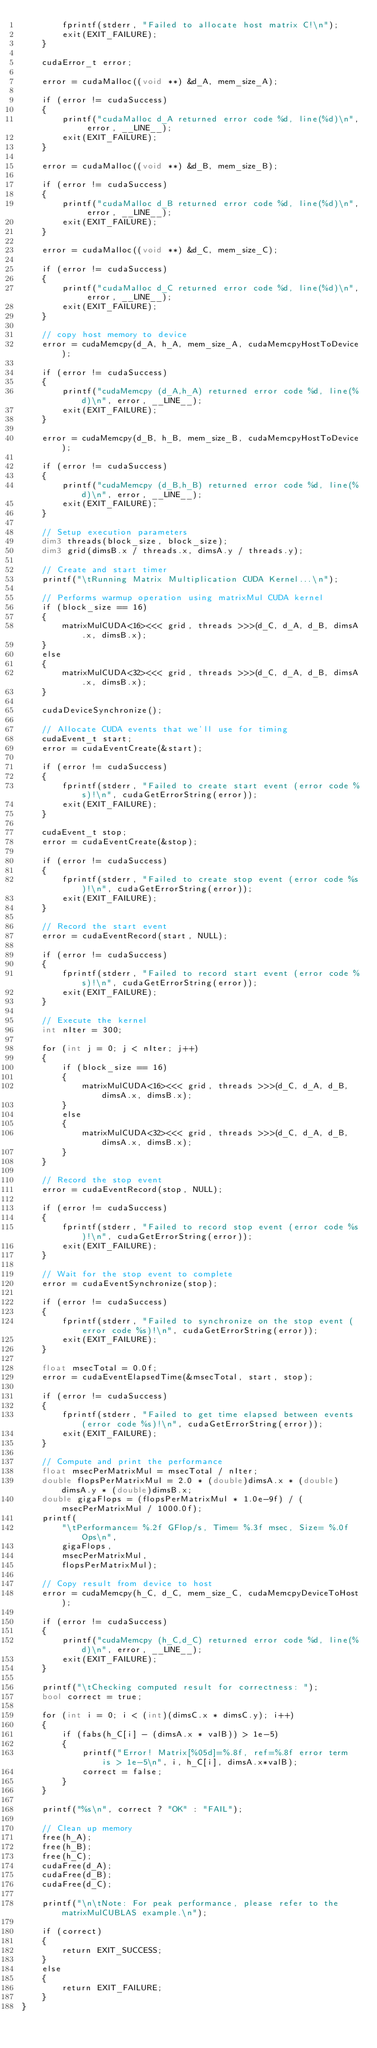<code> <loc_0><loc_0><loc_500><loc_500><_Cuda_>        fprintf(stderr, "Failed to allocate host matrix C!\n");
        exit(EXIT_FAILURE);
    }

    cudaError_t error;

    error = cudaMalloc((void **) &d_A, mem_size_A);

    if (error != cudaSuccess)
    {
        printf("cudaMalloc d_A returned error code %d, line(%d)\n", error, __LINE__);
        exit(EXIT_FAILURE);
    }

    error = cudaMalloc((void **) &d_B, mem_size_B);

    if (error != cudaSuccess)
    {
        printf("cudaMalloc d_B returned error code %d, line(%d)\n", error, __LINE__);
        exit(EXIT_FAILURE);
    }

    error = cudaMalloc((void **) &d_C, mem_size_C);

    if (error != cudaSuccess)
    {
        printf("cudaMalloc d_C returned error code %d, line(%d)\n", error, __LINE__);
        exit(EXIT_FAILURE);
    }

    // copy host memory to device
    error = cudaMemcpy(d_A, h_A, mem_size_A, cudaMemcpyHostToDevice);

    if (error != cudaSuccess)
    {
        printf("cudaMemcpy (d_A,h_A) returned error code %d, line(%d)\n", error, __LINE__);
        exit(EXIT_FAILURE);
    }

    error = cudaMemcpy(d_B, h_B, mem_size_B, cudaMemcpyHostToDevice);

    if (error != cudaSuccess)
    {
        printf("cudaMemcpy (d_B,h_B) returned error code %d, line(%d)\n", error, __LINE__);
        exit(EXIT_FAILURE);
    }

    // Setup execution parameters
    dim3 threads(block_size, block_size);
    dim3 grid(dimsB.x / threads.x, dimsA.y / threads.y);

    // Create and start timer
    printf("\tRunning Matrix Multiplication CUDA Kernel...\n");

    // Performs warmup operation using matrixMul CUDA kernel
    if (block_size == 16)
    {
        matrixMulCUDA<16><<< grid, threads >>>(d_C, d_A, d_B, dimsA.x, dimsB.x);
    }
    else
    {
        matrixMulCUDA<32><<< grid, threads >>>(d_C, d_A, d_B, dimsA.x, dimsB.x);
    }

    cudaDeviceSynchronize();

    // Allocate CUDA events that we'll use for timing
    cudaEvent_t start;
    error = cudaEventCreate(&start);

    if (error != cudaSuccess)
    {
        fprintf(stderr, "Failed to create start event (error code %s)!\n", cudaGetErrorString(error));
        exit(EXIT_FAILURE);
    }

    cudaEvent_t stop;
    error = cudaEventCreate(&stop);

    if (error != cudaSuccess)
    {
        fprintf(stderr, "Failed to create stop event (error code %s)!\n", cudaGetErrorString(error));
        exit(EXIT_FAILURE);
    }

    // Record the start event
    error = cudaEventRecord(start, NULL);

    if (error != cudaSuccess)
    {
        fprintf(stderr, "Failed to record start event (error code %s)!\n", cudaGetErrorString(error));
        exit(EXIT_FAILURE);
    }

    // Execute the kernel
    int nIter = 300;

    for (int j = 0; j < nIter; j++)
    {
        if (block_size == 16)
        {
            matrixMulCUDA<16><<< grid, threads >>>(d_C, d_A, d_B, dimsA.x, dimsB.x);
        }
        else
        {
            matrixMulCUDA<32><<< grid, threads >>>(d_C, d_A, d_B, dimsA.x, dimsB.x);
        }
    }

    // Record the stop event
    error = cudaEventRecord(stop, NULL);

    if (error != cudaSuccess)
    {
        fprintf(stderr, "Failed to record stop event (error code %s)!\n", cudaGetErrorString(error));
        exit(EXIT_FAILURE);
    }

    // Wait for the stop event to complete
    error = cudaEventSynchronize(stop);

    if (error != cudaSuccess)
    {
        fprintf(stderr, "Failed to synchronize on the stop event (error code %s)!\n", cudaGetErrorString(error));
        exit(EXIT_FAILURE);
    }

    float msecTotal = 0.0f;
    error = cudaEventElapsedTime(&msecTotal, start, stop);

    if (error != cudaSuccess)
    {
        fprintf(stderr, "Failed to get time elapsed between events (error code %s)!\n", cudaGetErrorString(error));
        exit(EXIT_FAILURE);
    }

    // Compute and print the performance
    float msecPerMatrixMul = msecTotal / nIter;
    double flopsPerMatrixMul = 2.0 * (double)dimsA.x * (double)dimsA.y * (double)dimsB.x;
    double gigaFlops = (flopsPerMatrixMul * 1.0e-9f) / (msecPerMatrixMul / 1000.0f);
    printf(
        "\tPerformance= %.2f GFlop/s, Time= %.3f msec, Size= %.0f Ops\n",
        gigaFlops,
        msecPerMatrixMul,
        flopsPerMatrixMul);

    // Copy result from device to host
    error = cudaMemcpy(h_C, d_C, mem_size_C, cudaMemcpyDeviceToHost);

    if (error != cudaSuccess)
    {
        printf("cudaMemcpy (h_C,d_C) returned error code %d, line(%d)\n", error, __LINE__);
        exit(EXIT_FAILURE);
    }

    printf("\tChecking computed result for correctness: ");
    bool correct = true;

    for (int i = 0; i < (int)(dimsC.x * dimsC.y); i++)
    {
        if (fabs(h_C[i] - (dimsA.x * valB)) > 1e-5)
        {
            printf("Error! Matrix[%05d]=%.8f, ref=%.8f error term is > 1e-5\n", i, h_C[i], dimsA.x*valB);
            correct = false;
        }
    }

    printf("%s\n", correct ? "OK" : "FAIL");

    // Clean up memory
    free(h_A);
    free(h_B);
    free(h_C);
    cudaFree(d_A);
    cudaFree(d_B);
    cudaFree(d_C);

    printf("\n\tNote: For peak performance, please refer to the matrixMulCUBLAS example.\n");

    if (correct)
    {
        return EXIT_SUCCESS;
    }
    else
    {
        return EXIT_FAILURE;
    }
}
</code> 